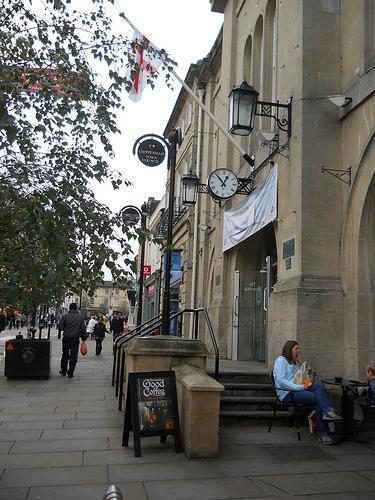How many people are yawning on the right side of the stair case?
Give a very brief answer. 1. 